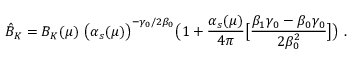<formula> <loc_0><loc_0><loc_500><loc_500>\hat { B } _ { K } = B _ { K } ( \mu ) \ \left ( \alpha _ { s } ( \mu ) \right ) ^ { - \gamma _ { 0 } / 2 \beta _ { 0 } } \left ( 1 + { \frac { \alpha _ { s } ( \mu ) } { 4 \pi } } \left [ { \frac { \beta _ { 1 } \gamma _ { 0 } - \beta _ { 0 } \gamma _ { 0 } } { 2 \beta _ { 0 } ^ { 2 } } } \right ] \right ) \ .</formula> 